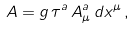Convert formula to latex. <formula><loc_0><loc_0><loc_500><loc_500>A = g \, \tau ^ { a } \, A _ { \mu } ^ { a } \, d x ^ { \mu } \, ,</formula> 